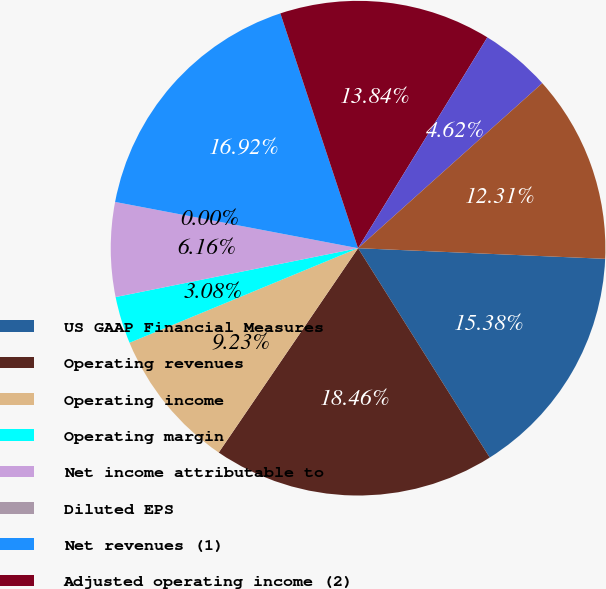<chart> <loc_0><loc_0><loc_500><loc_500><pie_chart><fcel>US GAAP Financial Measures<fcel>Operating revenues<fcel>Operating income<fcel>Operating margin<fcel>Net income attributable to<fcel>Diluted EPS<fcel>Net revenues (1)<fcel>Adjusted operating income (2)<fcel>Adjusted operating margin (2)<fcel>Adjusted net income<nl><fcel>15.38%<fcel>18.46%<fcel>9.23%<fcel>3.08%<fcel>6.16%<fcel>0.0%<fcel>16.92%<fcel>13.84%<fcel>4.62%<fcel>12.31%<nl></chart> 